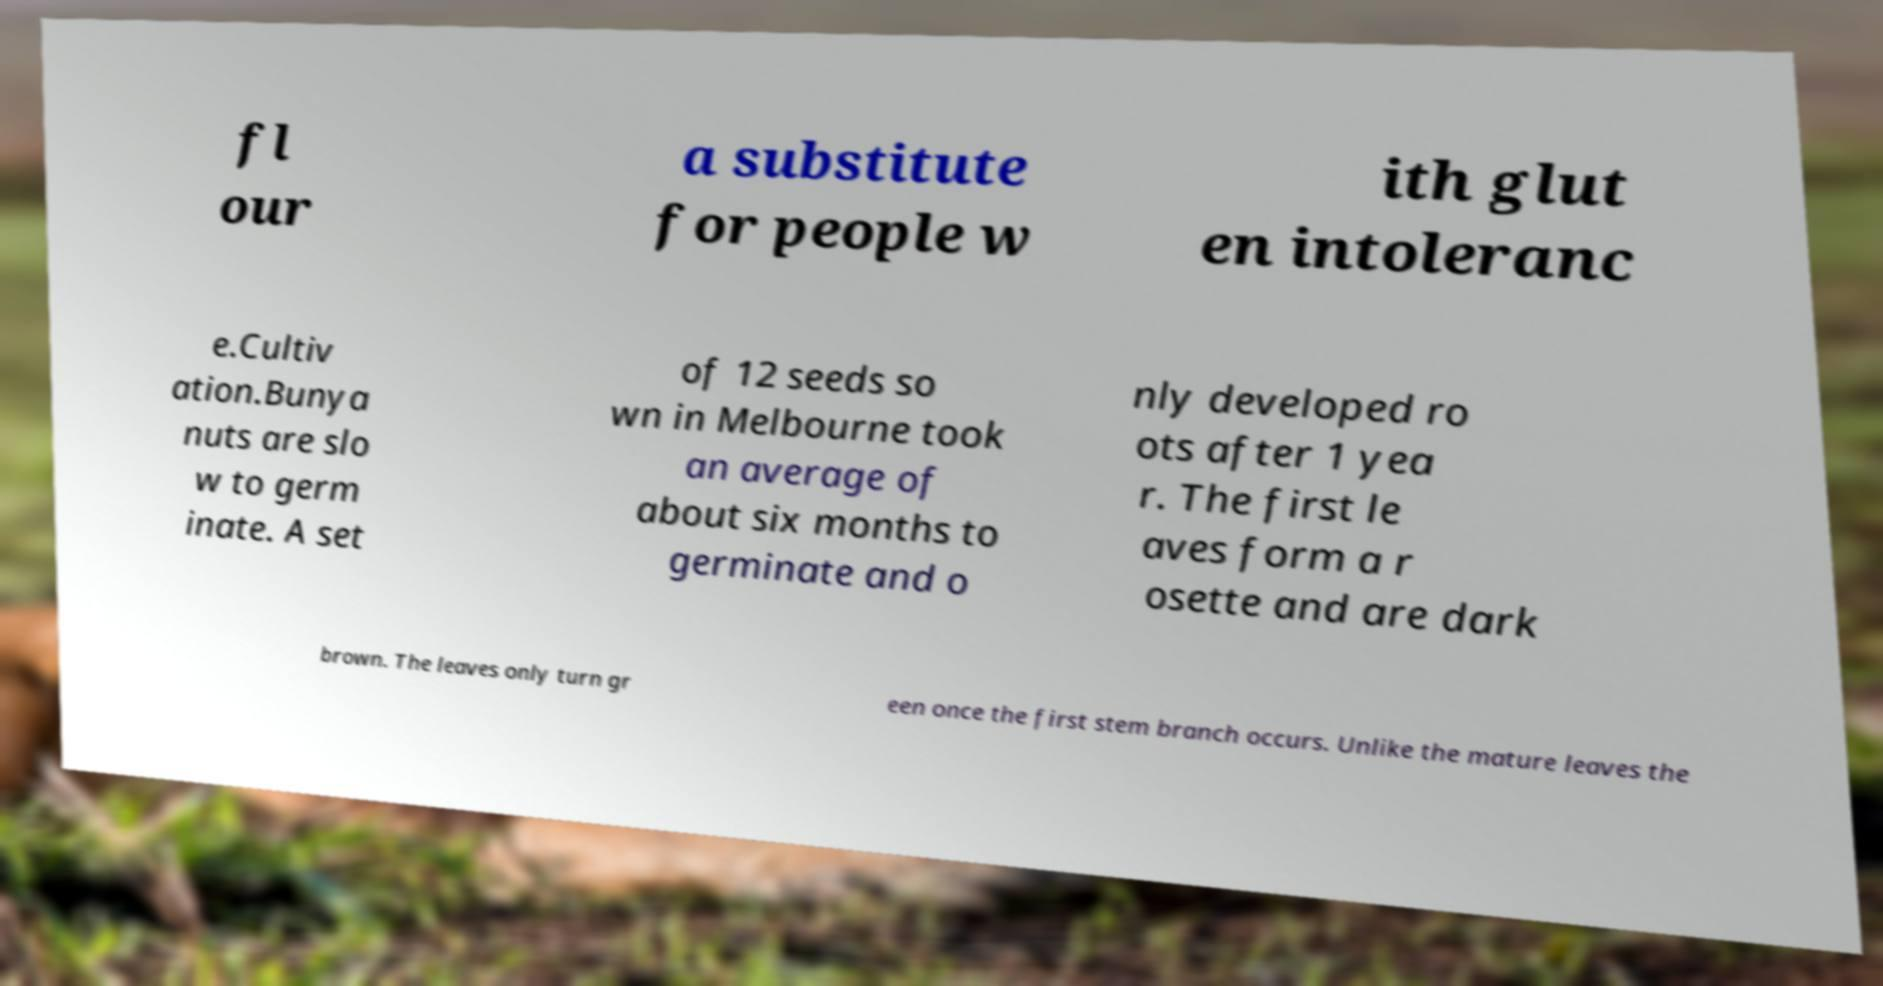Can you read and provide the text displayed in the image?This photo seems to have some interesting text. Can you extract and type it out for me? fl our a substitute for people w ith glut en intoleranc e.Cultiv ation.Bunya nuts are slo w to germ inate. A set of 12 seeds so wn in Melbourne took an average of about six months to germinate and o nly developed ro ots after 1 yea r. The first le aves form a r osette and are dark brown. The leaves only turn gr een once the first stem branch occurs. Unlike the mature leaves the 